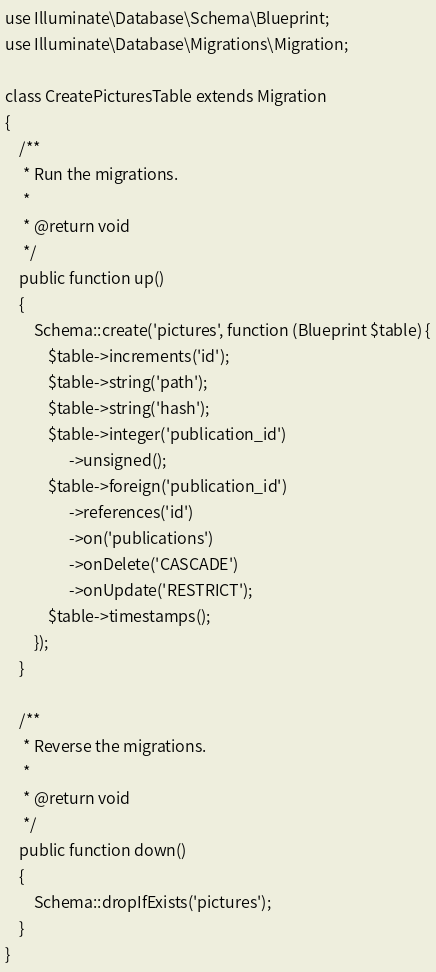Convert code to text. <code><loc_0><loc_0><loc_500><loc_500><_PHP_>use Illuminate\Database\Schema\Blueprint;
use Illuminate\Database\Migrations\Migration;

class CreatePicturesTable extends Migration
{
    /**
     * Run the migrations.
     *
     * @return void
     */
    public function up()
    {
        Schema::create('pictures', function (Blueprint $table) {
            $table->increments('id');
			$table->string('path');
			$table->string('hash');
			$table->integer('publication_id')  
                  ->unsigned();   
			$table->foreign('publication_id')  
                  ->references('id')            
                  ->on('publications')         
                  ->onDelete('CASCADE') 
				  ->onUpdate('RESTRICT');
            $table->timestamps();
        });
    }

    /**
     * Reverse the migrations.
     *
     * @return void
     */
    public function down()
    {
        Schema::dropIfExists('pictures');
    }
}
</code> 